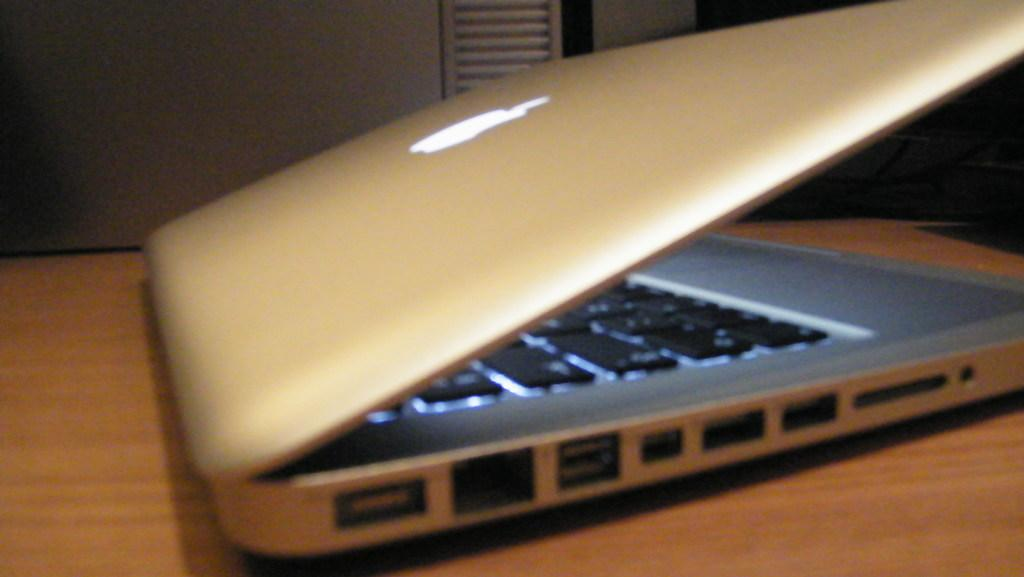What electronic device is visible in the picture? There is a laptop in the picture. Where is the laptop placed? The laptop is placed on a wooden table. What feature can be seen on the laptop's keyboard? The laptop has lights arranged in the keyboard. What brand or company might be represented by the logo on the laptop? There is a logo on the laptop, which could indicate the brand or company. What can be seen in the background of the picture? There is a wall in the background of the picture. What type of hammer is being used to mine quartz in the image? There is no hammer or quartz present in the image; it features a laptop placed on a wooden table. What insect is crawling on the wall in the background of the image? There is no insect visible on the wall in the background of the image. 